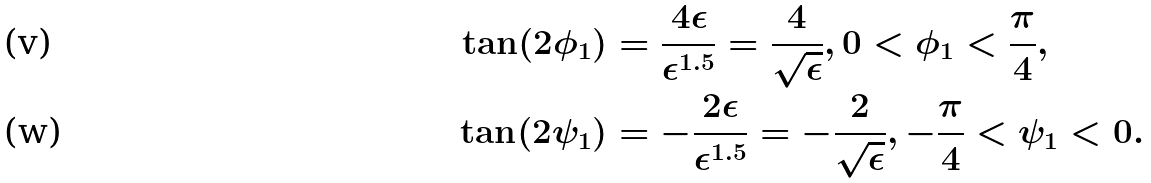<formula> <loc_0><loc_0><loc_500><loc_500>\tan ( 2 \phi _ { 1 } ) & = \frac { 4 \epsilon } { \epsilon ^ { 1 . 5 } } = \frac { 4 } { \sqrt { \epsilon } } , 0 < \phi _ { 1 } < \frac { \pi } { 4 } , \\ \tan ( 2 \psi _ { 1 } ) & = - \frac { 2 \epsilon } { \epsilon ^ { 1 . 5 } } = - \frac { 2 } { \sqrt { \epsilon } } , - \frac { \pi } { 4 } < \psi _ { 1 } < 0 .</formula> 